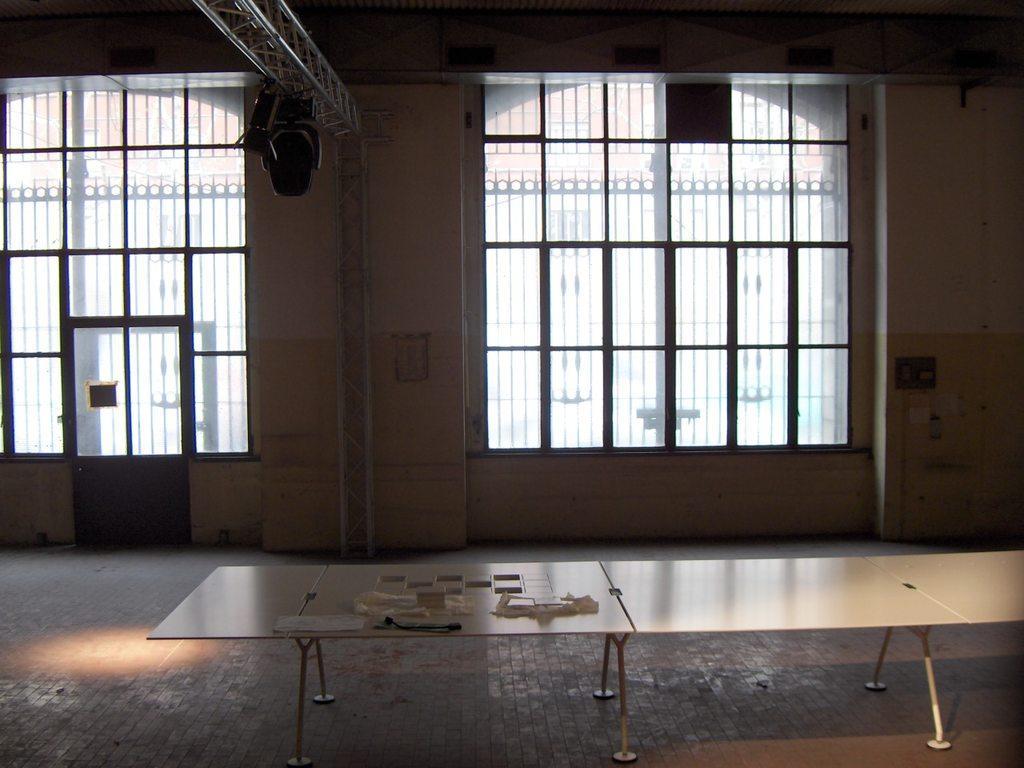Describe this image in one or two sentences. In this picture there is a table which has few objects placed on it and there is a pole which has two black color object attached to it and there are few glass windows in the background. 